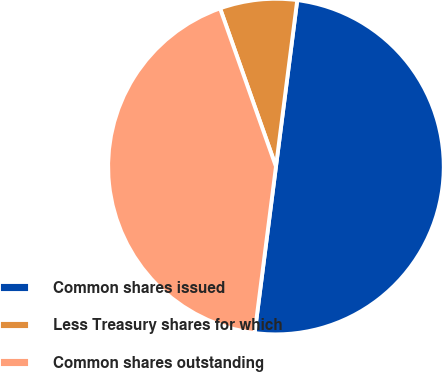Convert chart to OTSL. <chart><loc_0><loc_0><loc_500><loc_500><pie_chart><fcel>Common shares issued<fcel>Less Treasury shares for which<fcel>Common shares outstanding<nl><fcel>50.0%<fcel>7.43%<fcel>42.57%<nl></chart> 